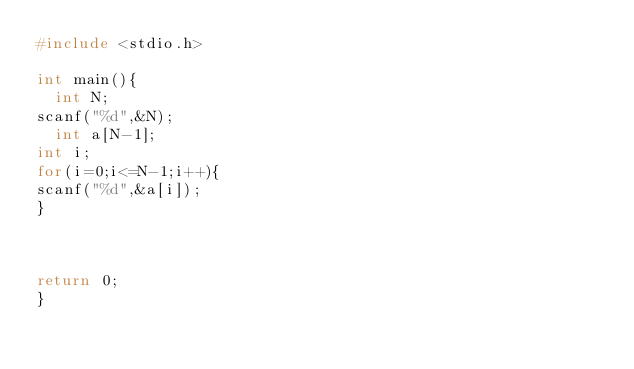<code> <loc_0><loc_0><loc_500><loc_500><_C_>#include <stdio.h>

int main(){
  int N;
scanf("%d",&N);
  int a[N-1];
int i;
for(i=0;i<=N-1;i++){
scanf("%d",&a[i]);
}



return 0;
}
</code> 